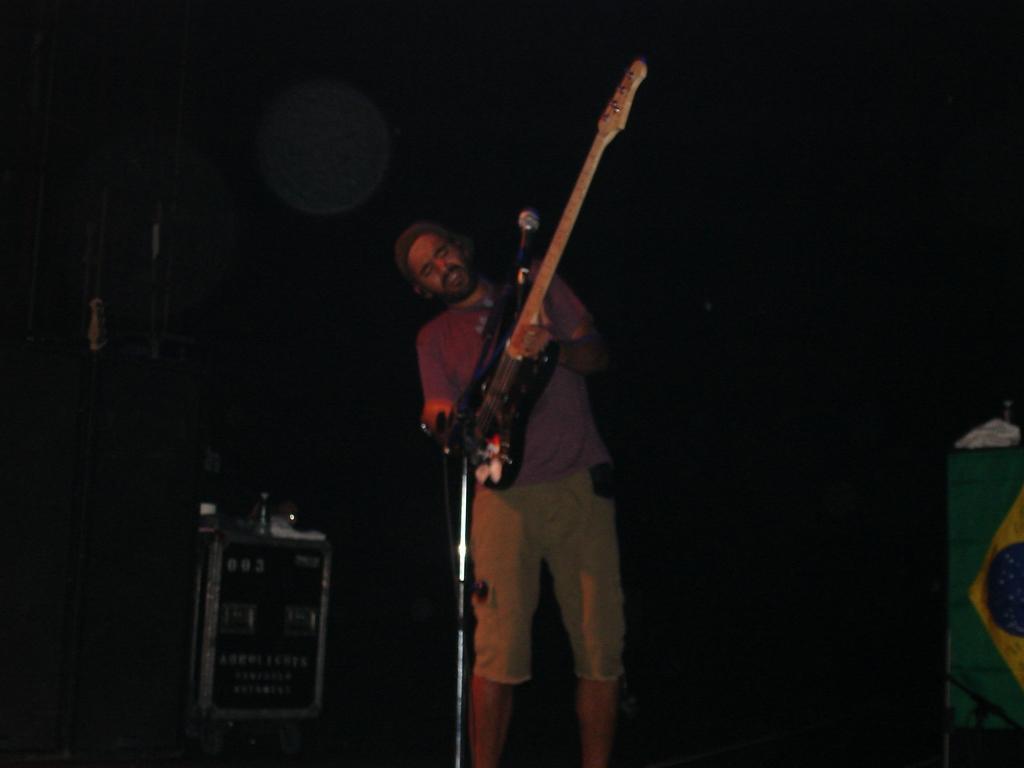Can you describe this image briefly? There is a person standing in the center. He is playing a guitar and singing on a microphone. 